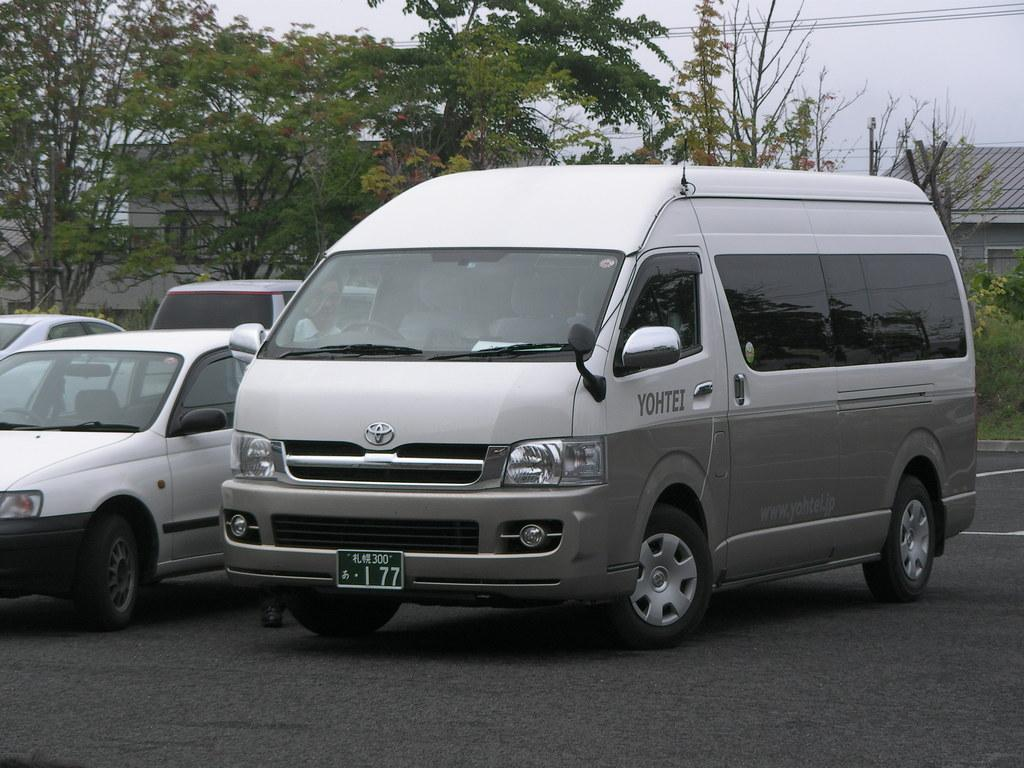Provide a one-sentence caption for the provided image. A white and gray van is parked with YOHTEI on the driver's side door. 